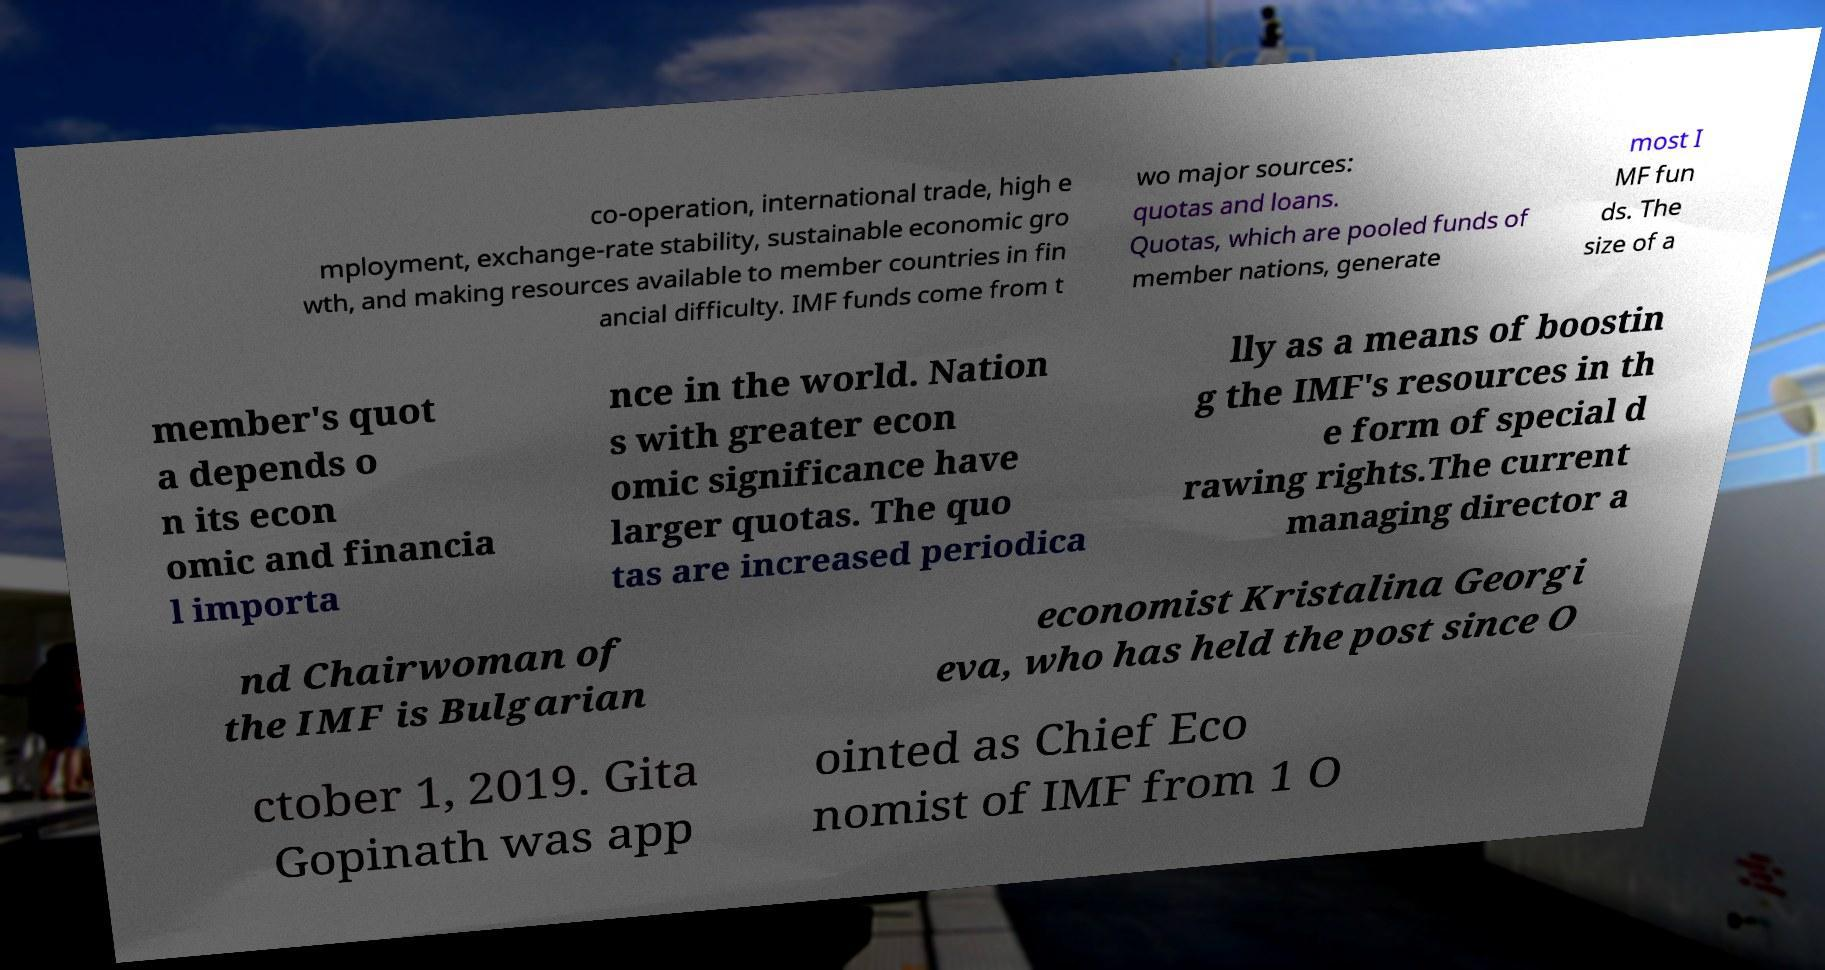Can you accurately transcribe the text from the provided image for me? co-operation, international trade, high e mployment, exchange-rate stability, sustainable economic gro wth, and making resources available to member countries in fin ancial difficulty. IMF funds come from t wo major sources: quotas and loans. Quotas, which are pooled funds of member nations, generate most I MF fun ds. The size of a member's quot a depends o n its econ omic and financia l importa nce in the world. Nation s with greater econ omic significance have larger quotas. The quo tas are increased periodica lly as a means of boostin g the IMF's resources in th e form of special d rawing rights.The current managing director a nd Chairwoman of the IMF is Bulgarian economist Kristalina Georgi eva, who has held the post since O ctober 1, 2019. Gita Gopinath was app ointed as Chief Eco nomist of IMF from 1 O 